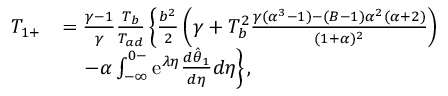Convert formula to latex. <formula><loc_0><loc_0><loc_500><loc_500>\begin{array} { r l } { T _ { 1 + } } & { = \frac { \gamma - 1 } { \gamma } \frac { T _ { b } } { T _ { a d } } \left \{ \frac { b ^ { 2 } } { 2 } \left ( \gamma + T _ { b } ^ { 2 } \frac { \gamma ( \alpha ^ { 3 } - 1 ) - ( B - 1 ) \alpha ^ { 2 } ( \alpha + 2 ) } { ( 1 + \alpha ) ^ { 2 } } \right ) } \\ & { \quad - \alpha \int _ { - \infty } ^ { 0 - } e ^ { \lambda \eta } \frac { d \hat { \theta } _ { 1 } } { d \eta } d \eta \right \} , } \end{array}</formula> 